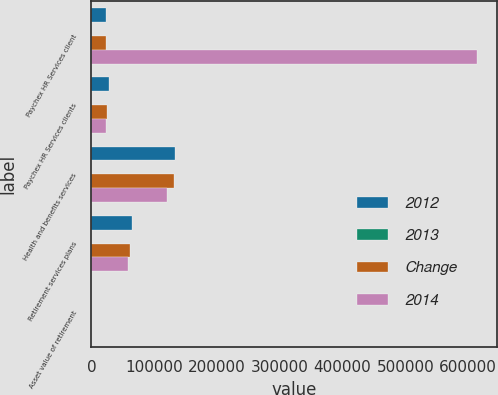Convert chart to OTSL. <chart><loc_0><loc_0><loc_500><loc_500><stacked_bar_chart><ecel><fcel>Paychex HR Services client<fcel>Paychex HR Services clients<fcel>Health and benefits services<fcel>Retirement services plans<fcel>Asset value of retirement<nl><fcel>2012<fcel>24000<fcel>28000<fcel>134000<fcel>65000<fcel>21.9<nl><fcel>2013<fcel>14<fcel>13<fcel>3<fcel>5<fcel>13<nl><fcel>Change<fcel>24000<fcel>25000<fcel>131000<fcel>62000<fcel>19.3<nl><fcel>2014<fcel>615000<fcel>23000<fcel>121000<fcel>59000<fcel>15.7<nl></chart> 